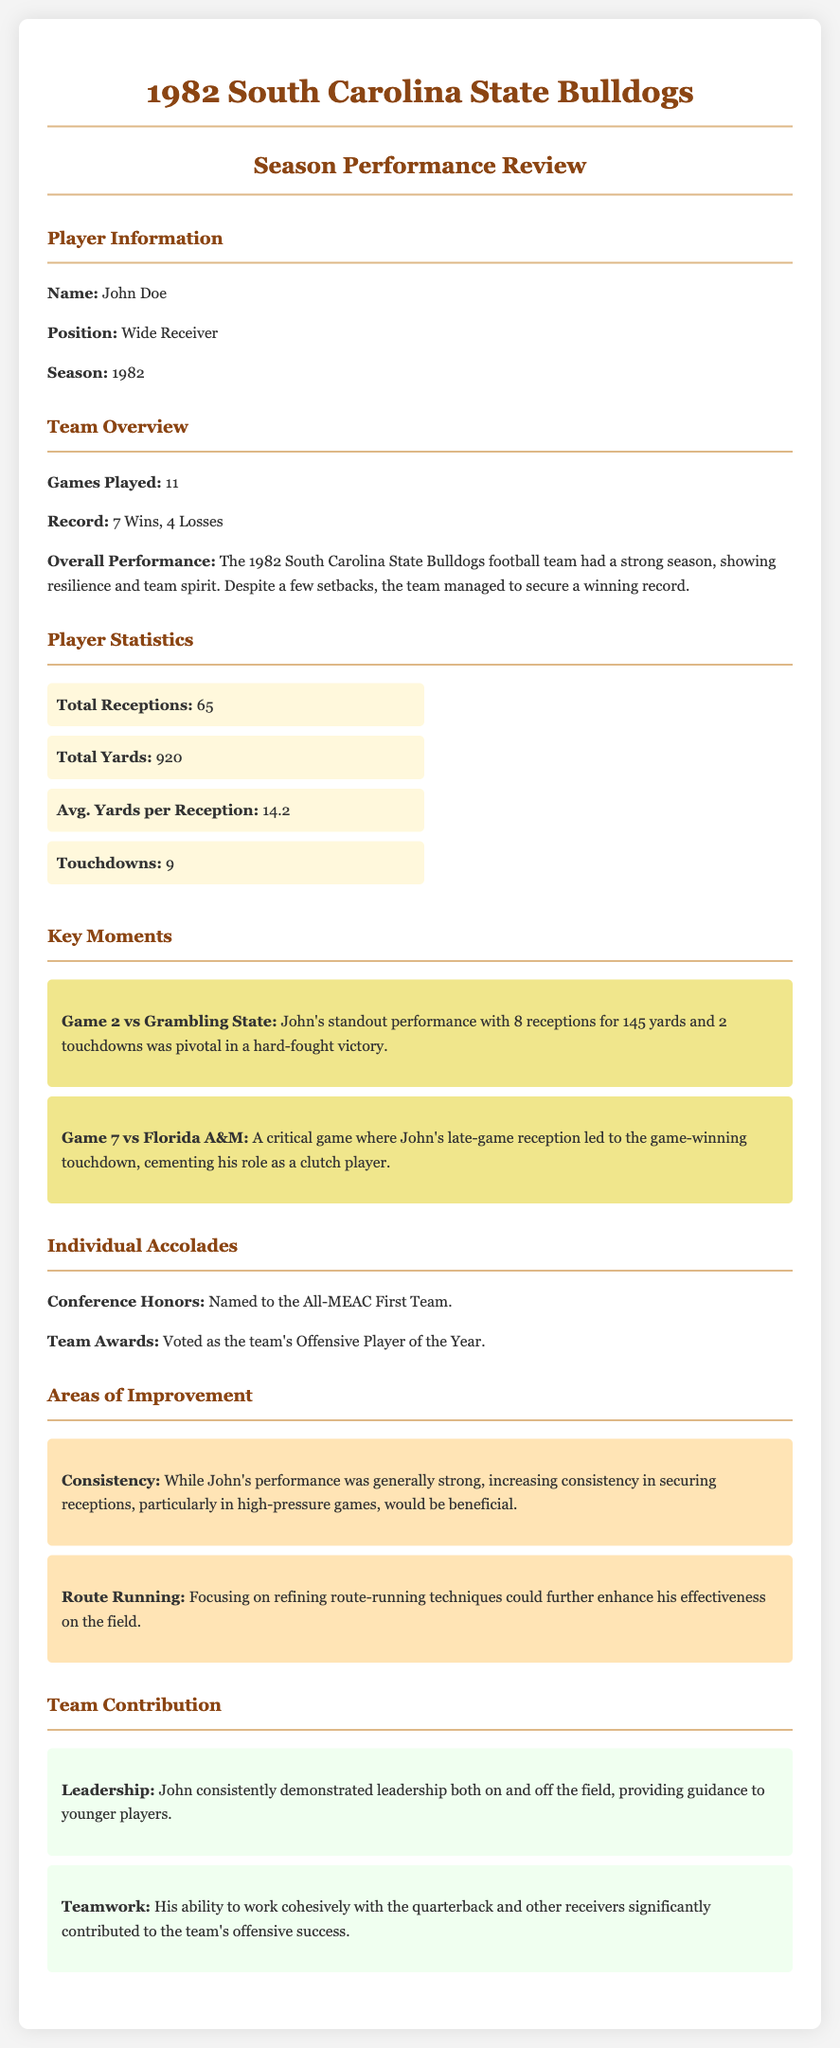what is the player's name? The player's name is mentioned at the beginning in the Player Information section.
Answer: John Doe what position did the player hold? The position is specified under Player Information.
Answer: Wide Receiver how many games did the team play? The number of games played is indicated in the Team Overview section.
Answer: 11 what was the team's win-loss record? The record is presented in the Team Overview section.
Answer: 7 Wins, 4 Losses how many touchdowns did the player score? The total number of touchdowns is found in the Player Statistics section.
Answer: 9 which game featured the player's standout performance? The key moment points to the game in which the player excelled.
Answer: Game 2 vs Grambling State what accolade did the player receive? The recognition received by the player is noted in the Individual Accolades section.
Answer: All-MEAC First Team what area does the player need to improve? The areas of improvement are listed in the relevant section.
Answer: Consistency how did the player contribute to team leadership? The contribution to leadership is outlined in the Team Contribution section.
Answer: Guidance to younger players 